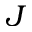<formula> <loc_0><loc_0><loc_500><loc_500>J</formula> 